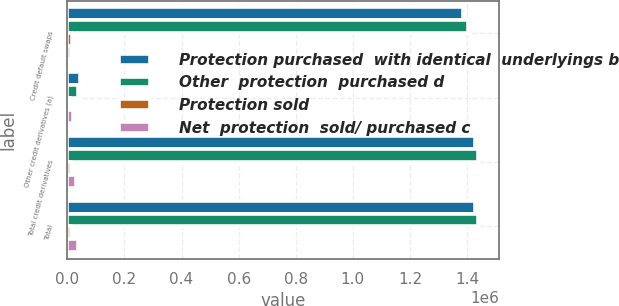Convert chart to OTSL. <chart><loc_0><loc_0><loc_500><loc_500><stacked_bar_chart><ecel><fcel>Credit default swaps<fcel>Other credit derivatives (a)<fcel>Total credit derivatives<fcel>Total<nl><fcel>Protection purchased  with identical  underlyings b<fcel>1.38607e+06<fcel>42738<fcel>1.42881e+06<fcel>1.42884e+06<nl><fcel>Other  protection  purchased d<fcel>1.4022e+06<fcel>38158<fcel>1.44036e+06<fcel>1.44036e+06<nl><fcel>Protection sold<fcel>16130<fcel>4580<fcel>11550<fcel>11520<nl><fcel>Net  protection  sold/ purchased c<fcel>12011<fcel>18792<fcel>30803<fcel>35518<nl></chart> 